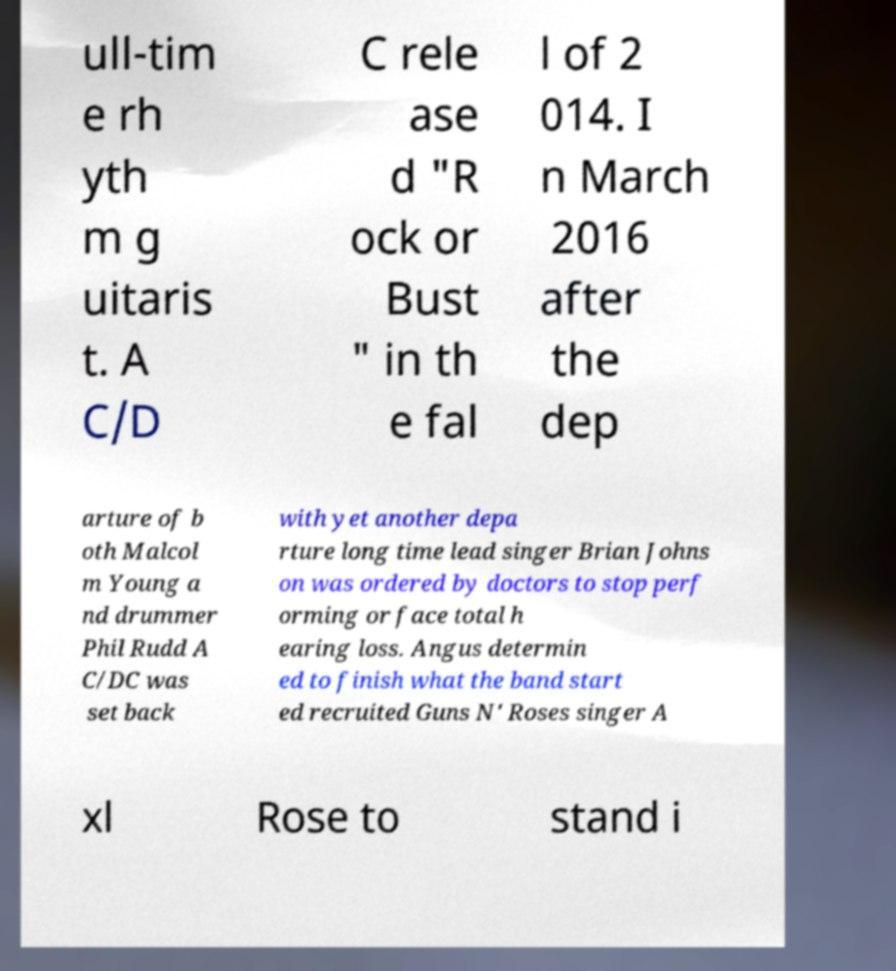Can you read and provide the text displayed in the image?This photo seems to have some interesting text. Can you extract and type it out for me? ull-tim e rh yth m g uitaris t. A C/D C rele ase d "R ock or Bust " in th e fal l of 2 014. I n March 2016 after the dep arture of b oth Malcol m Young a nd drummer Phil Rudd A C/DC was set back with yet another depa rture long time lead singer Brian Johns on was ordered by doctors to stop perf orming or face total h earing loss. Angus determin ed to finish what the band start ed recruited Guns N' Roses singer A xl Rose to stand i 